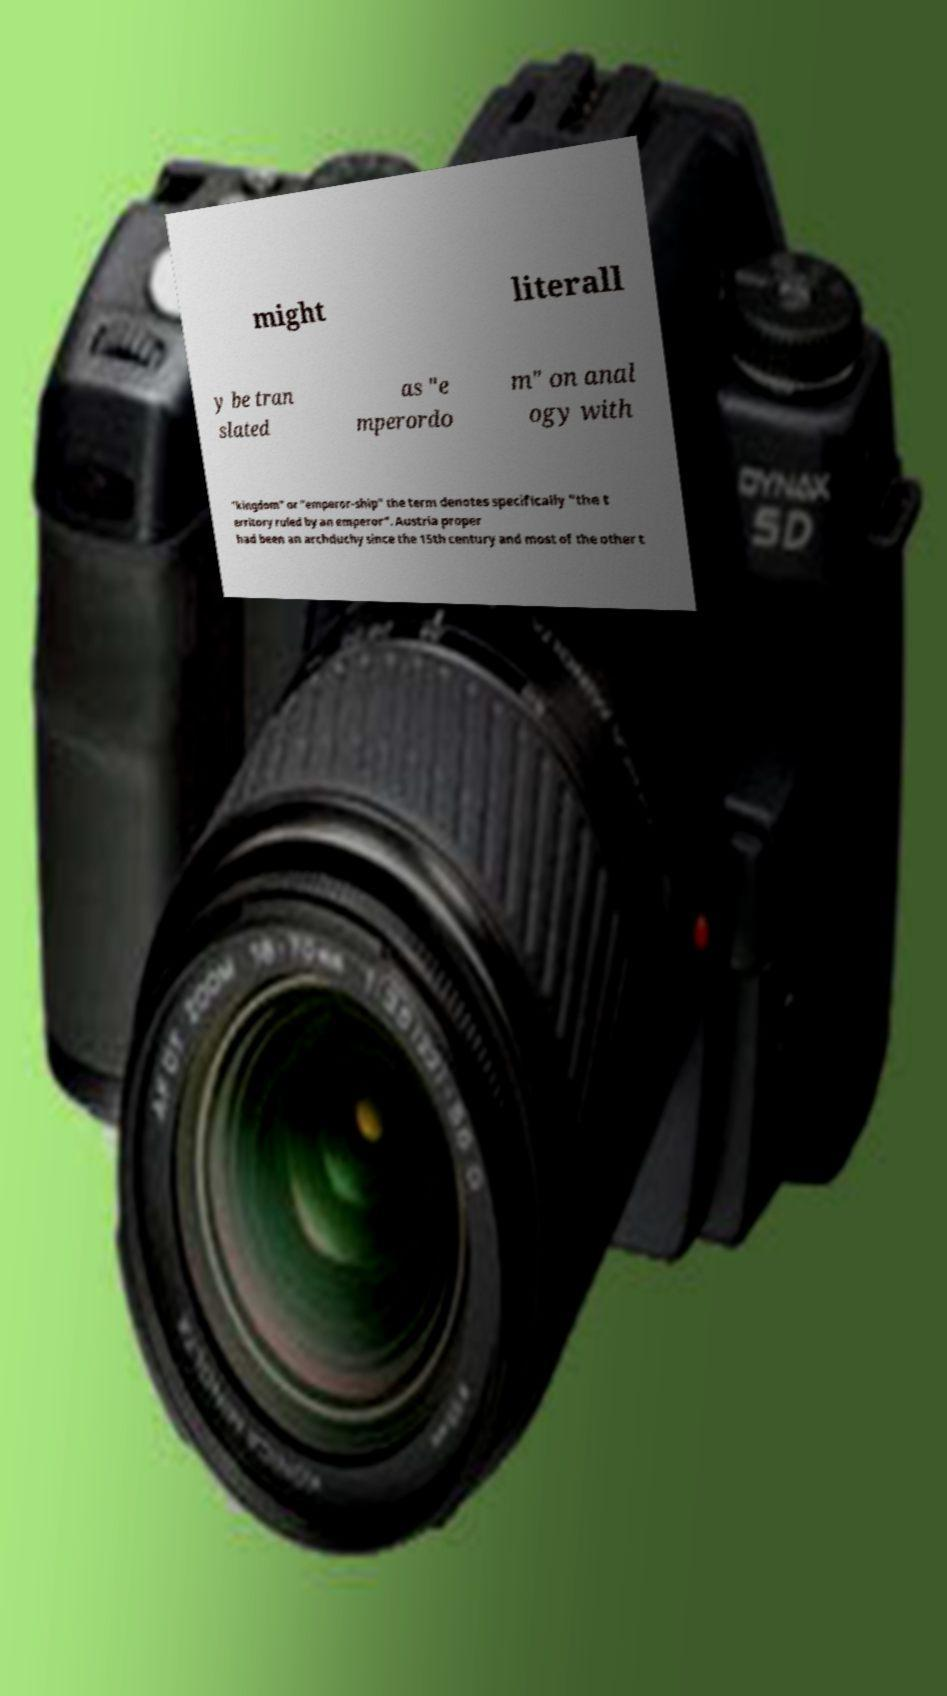Can you read and provide the text displayed in the image?This photo seems to have some interesting text. Can you extract and type it out for me? might literall y be tran slated as "e mperordo m" on anal ogy with "kingdom" or "emperor-ship" the term denotes specifically "the t erritory ruled by an emperor". Austria proper had been an archduchy since the 15th century and most of the other t 